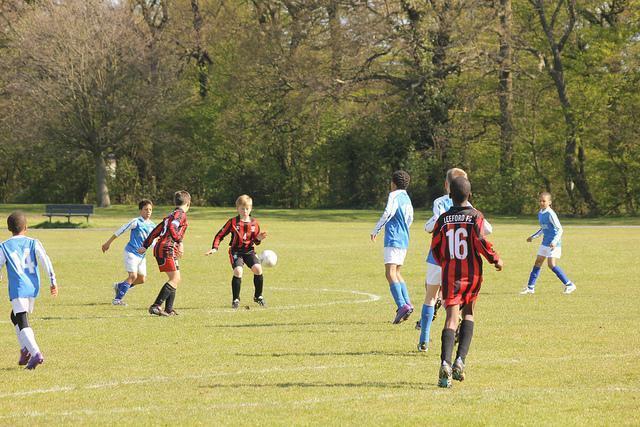How many people are pictured?
Give a very brief answer. 8. How many people are playing?
Give a very brief answer. 8. How many children wear blue and white uniforms?
Give a very brief answer. 5. How many people are in the photo?
Give a very brief answer. 8. 